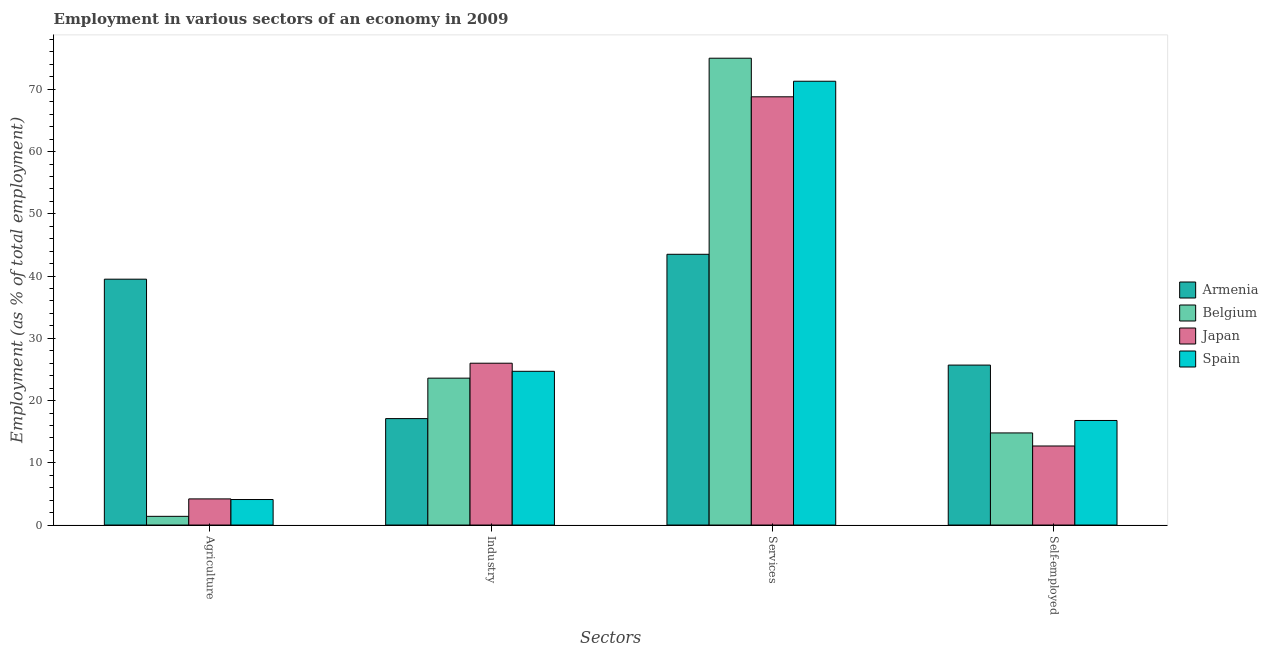How many bars are there on the 4th tick from the left?
Offer a very short reply. 4. What is the label of the 2nd group of bars from the left?
Offer a very short reply. Industry. What is the percentage of self employed workers in Spain?
Provide a succinct answer. 16.8. Across all countries, what is the maximum percentage of workers in agriculture?
Your answer should be very brief. 39.5. Across all countries, what is the minimum percentage of workers in industry?
Ensure brevity in your answer.  17.1. In which country was the percentage of workers in agriculture maximum?
Give a very brief answer. Armenia. In which country was the percentage of workers in agriculture minimum?
Offer a terse response. Belgium. What is the total percentage of self employed workers in the graph?
Offer a very short reply. 70. What is the difference between the percentage of workers in industry in Japan and that in Armenia?
Your answer should be very brief. 8.9. What is the difference between the percentage of workers in services in Spain and the percentage of workers in industry in Belgium?
Your answer should be compact. 47.7. What is the average percentage of self employed workers per country?
Ensure brevity in your answer.  17.5. What is the difference between the percentage of workers in industry and percentage of workers in services in Belgium?
Your response must be concise. -51.4. What is the ratio of the percentage of self employed workers in Spain to that in Belgium?
Your answer should be very brief. 1.14. Is the percentage of workers in agriculture in Spain less than that in Belgium?
Your answer should be compact. No. Is the difference between the percentage of self employed workers in Armenia and Spain greater than the difference between the percentage of workers in industry in Armenia and Spain?
Give a very brief answer. Yes. What is the difference between the highest and the second highest percentage of self employed workers?
Keep it short and to the point. 8.9. What is the difference between the highest and the lowest percentage of workers in industry?
Make the answer very short. 8.9. What does the 1st bar from the left in Services represents?
Your response must be concise. Armenia. What does the 4th bar from the right in Self-employed represents?
Offer a very short reply. Armenia. Does the graph contain any zero values?
Ensure brevity in your answer.  No. Where does the legend appear in the graph?
Offer a very short reply. Center right. What is the title of the graph?
Make the answer very short. Employment in various sectors of an economy in 2009. Does "Vanuatu" appear as one of the legend labels in the graph?
Offer a terse response. No. What is the label or title of the X-axis?
Provide a short and direct response. Sectors. What is the label or title of the Y-axis?
Your response must be concise. Employment (as % of total employment). What is the Employment (as % of total employment) in Armenia in Agriculture?
Offer a terse response. 39.5. What is the Employment (as % of total employment) in Belgium in Agriculture?
Offer a very short reply. 1.4. What is the Employment (as % of total employment) of Japan in Agriculture?
Make the answer very short. 4.2. What is the Employment (as % of total employment) in Spain in Agriculture?
Your response must be concise. 4.1. What is the Employment (as % of total employment) in Armenia in Industry?
Your answer should be compact. 17.1. What is the Employment (as % of total employment) in Belgium in Industry?
Offer a very short reply. 23.6. What is the Employment (as % of total employment) in Spain in Industry?
Offer a terse response. 24.7. What is the Employment (as % of total employment) in Armenia in Services?
Make the answer very short. 43.5. What is the Employment (as % of total employment) in Japan in Services?
Provide a short and direct response. 68.8. What is the Employment (as % of total employment) of Spain in Services?
Your answer should be very brief. 71.3. What is the Employment (as % of total employment) of Armenia in Self-employed?
Provide a short and direct response. 25.7. What is the Employment (as % of total employment) in Belgium in Self-employed?
Ensure brevity in your answer.  14.8. What is the Employment (as % of total employment) in Japan in Self-employed?
Offer a terse response. 12.7. What is the Employment (as % of total employment) in Spain in Self-employed?
Your answer should be very brief. 16.8. Across all Sectors, what is the maximum Employment (as % of total employment) of Armenia?
Give a very brief answer. 43.5. Across all Sectors, what is the maximum Employment (as % of total employment) of Belgium?
Offer a terse response. 75. Across all Sectors, what is the maximum Employment (as % of total employment) of Japan?
Make the answer very short. 68.8. Across all Sectors, what is the maximum Employment (as % of total employment) in Spain?
Ensure brevity in your answer.  71.3. Across all Sectors, what is the minimum Employment (as % of total employment) of Armenia?
Keep it short and to the point. 17.1. Across all Sectors, what is the minimum Employment (as % of total employment) of Belgium?
Provide a succinct answer. 1.4. Across all Sectors, what is the minimum Employment (as % of total employment) in Japan?
Provide a short and direct response. 4.2. Across all Sectors, what is the minimum Employment (as % of total employment) of Spain?
Your response must be concise. 4.1. What is the total Employment (as % of total employment) of Armenia in the graph?
Your answer should be compact. 125.8. What is the total Employment (as % of total employment) in Belgium in the graph?
Your answer should be very brief. 114.8. What is the total Employment (as % of total employment) in Japan in the graph?
Your answer should be very brief. 111.7. What is the total Employment (as % of total employment) of Spain in the graph?
Make the answer very short. 116.9. What is the difference between the Employment (as % of total employment) in Armenia in Agriculture and that in Industry?
Give a very brief answer. 22.4. What is the difference between the Employment (as % of total employment) of Belgium in Agriculture and that in Industry?
Offer a terse response. -22.2. What is the difference between the Employment (as % of total employment) of Japan in Agriculture and that in Industry?
Ensure brevity in your answer.  -21.8. What is the difference between the Employment (as % of total employment) in Spain in Agriculture and that in Industry?
Your response must be concise. -20.6. What is the difference between the Employment (as % of total employment) in Belgium in Agriculture and that in Services?
Your answer should be very brief. -73.6. What is the difference between the Employment (as % of total employment) of Japan in Agriculture and that in Services?
Offer a very short reply. -64.6. What is the difference between the Employment (as % of total employment) in Spain in Agriculture and that in Services?
Your answer should be very brief. -67.2. What is the difference between the Employment (as % of total employment) of Belgium in Agriculture and that in Self-employed?
Provide a short and direct response. -13.4. What is the difference between the Employment (as % of total employment) of Japan in Agriculture and that in Self-employed?
Give a very brief answer. -8.5. What is the difference between the Employment (as % of total employment) in Armenia in Industry and that in Services?
Make the answer very short. -26.4. What is the difference between the Employment (as % of total employment) of Belgium in Industry and that in Services?
Offer a terse response. -51.4. What is the difference between the Employment (as % of total employment) of Japan in Industry and that in Services?
Keep it short and to the point. -42.8. What is the difference between the Employment (as % of total employment) of Spain in Industry and that in Services?
Offer a terse response. -46.6. What is the difference between the Employment (as % of total employment) of Armenia in Industry and that in Self-employed?
Make the answer very short. -8.6. What is the difference between the Employment (as % of total employment) in Belgium in Industry and that in Self-employed?
Offer a very short reply. 8.8. What is the difference between the Employment (as % of total employment) of Japan in Industry and that in Self-employed?
Provide a succinct answer. 13.3. What is the difference between the Employment (as % of total employment) of Belgium in Services and that in Self-employed?
Make the answer very short. 60.2. What is the difference between the Employment (as % of total employment) in Japan in Services and that in Self-employed?
Provide a short and direct response. 56.1. What is the difference between the Employment (as % of total employment) of Spain in Services and that in Self-employed?
Keep it short and to the point. 54.5. What is the difference between the Employment (as % of total employment) of Armenia in Agriculture and the Employment (as % of total employment) of Spain in Industry?
Your answer should be compact. 14.8. What is the difference between the Employment (as % of total employment) of Belgium in Agriculture and the Employment (as % of total employment) of Japan in Industry?
Offer a terse response. -24.6. What is the difference between the Employment (as % of total employment) in Belgium in Agriculture and the Employment (as % of total employment) in Spain in Industry?
Ensure brevity in your answer.  -23.3. What is the difference between the Employment (as % of total employment) of Japan in Agriculture and the Employment (as % of total employment) of Spain in Industry?
Give a very brief answer. -20.5. What is the difference between the Employment (as % of total employment) of Armenia in Agriculture and the Employment (as % of total employment) of Belgium in Services?
Give a very brief answer. -35.5. What is the difference between the Employment (as % of total employment) of Armenia in Agriculture and the Employment (as % of total employment) of Japan in Services?
Provide a succinct answer. -29.3. What is the difference between the Employment (as % of total employment) of Armenia in Agriculture and the Employment (as % of total employment) of Spain in Services?
Give a very brief answer. -31.8. What is the difference between the Employment (as % of total employment) in Belgium in Agriculture and the Employment (as % of total employment) in Japan in Services?
Your answer should be very brief. -67.4. What is the difference between the Employment (as % of total employment) in Belgium in Agriculture and the Employment (as % of total employment) in Spain in Services?
Ensure brevity in your answer.  -69.9. What is the difference between the Employment (as % of total employment) in Japan in Agriculture and the Employment (as % of total employment) in Spain in Services?
Provide a short and direct response. -67.1. What is the difference between the Employment (as % of total employment) of Armenia in Agriculture and the Employment (as % of total employment) of Belgium in Self-employed?
Make the answer very short. 24.7. What is the difference between the Employment (as % of total employment) in Armenia in Agriculture and the Employment (as % of total employment) in Japan in Self-employed?
Your answer should be very brief. 26.8. What is the difference between the Employment (as % of total employment) of Armenia in Agriculture and the Employment (as % of total employment) of Spain in Self-employed?
Offer a terse response. 22.7. What is the difference between the Employment (as % of total employment) in Belgium in Agriculture and the Employment (as % of total employment) in Spain in Self-employed?
Give a very brief answer. -15.4. What is the difference between the Employment (as % of total employment) in Japan in Agriculture and the Employment (as % of total employment) in Spain in Self-employed?
Offer a terse response. -12.6. What is the difference between the Employment (as % of total employment) in Armenia in Industry and the Employment (as % of total employment) in Belgium in Services?
Your response must be concise. -57.9. What is the difference between the Employment (as % of total employment) in Armenia in Industry and the Employment (as % of total employment) in Japan in Services?
Make the answer very short. -51.7. What is the difference between the Employment (as % of total employment) of Armenia in Industry and the Employment (as % of total employment) of Spain in Services?
Make the answer very short. -54.2. What is the difference between the Employment (as % of total employment) of Belgium in Industry and the Employment (as % of total employment) of Japan in Services?
Provide a short and direct response. -45.2. What is the difference between the Employment (as % of total employment) in Belgium in Industry and the Employment (as % of total employment) in Spain in Services?
Provide a succinct answer. -47.7. What is the difference between the Employment (as % of total employment) of Japan in Industry and the Employment (as % of total employment) of Spain in Services?
Give a very brief answer. -45.3. What is the difference between the Employment (as % of total employment) of Armenia in Industry and the Employment (as % of total employment) of Belgium in Self-employed?
Keep it short and to the point. 2.3. What is the difference between the Employment (as % of total employment) of Armenia in Industry and the Employment (as % of total employment) of Japan in Self-employed?
Give a very brief answer. 4.4. What is the difference between the Employment (as % of total employment) of Japan in Industry and the Employment (as % of total employment) of Spain in Self-employed?
Provide a succinct answer. 9.2. What is the difference between the Employment (as % of total employment) in Armenia in Services and the Employment (as % of total employment) in Belgium in Self-employed?
Keep it short and to the point. 28.7. What is the difference between the Employment (as % of total employment) in Armenia in Services and the Employment (as % of total employment) in Japan in Self-employed?
Provide a succinct answer. 30.8. What is the difference between the Employment (as % of total employment) in Armenia in Services and the Employment (as % of total employment) in Spain in Self-employed?
Offer a very short reply. 26.7. What is the difference between the Employment (as % of total employment) in Belgium in Services and the Employment (as % of total employment) in Japan in Self-employed?
Give a very brief answer. 62.3. What is the difference between the Employment (as % of total employment) of Belgium in Services and the Employment (as % of total employment) of Spain in Self-employed?
Give a very brief answer. 58.2. What is the average Employment (as % of total employment) of Armenia per Sectors?
Make the answer very short. 31.45. What is the average Employment (as % of total employment) of Belgium per Sectors?
Give a very brief answer. 28.7. What is the average Employment (as % of total employment) in Japan per Sectors?
Give a very brief answer. 27.93. What is the average Employment (as % of total employment) of Spain per Sectors?
Ensure brevity in your answer.  29.23. What is the difference between the Employment (as % of total employment) of Armenia and Employment (as % of total employment) of Belgium in Agriculture?
Give a very brief answer. 38.1. What is the difference between the Employment (as % of total employment) in Armenia and Employment (as % of total employment) in Japan in Agriculture?
Offer a very short reply. 35.3. What is the difference between the Employment (as % of total employment) in Armenia and Employment (as % of total employment) in Spain in Agriculture?
Keep it short and to the point. 35.4. What is the difference between the Employment (as % of total employment) of Belgium and Employment (as % of total employment) of Japan in Agriculture?
Offer a very short reply. -2.8. What is the difference between the Employment (as % of total employment) of Belgium and Employment (as % of total employment) of Spain in Agriculture?
Keep it short and to the point. -2.7. What is the difference between the Employment (as % of total employment) in Japan and Employment (as % of total employment) in Spain in Agriculture?
Offer a terse response. 0.1. What is the difference between the Employment (as % of total employment) in Armenia and Employment (as % of total employment) in Belgium in Industry?
Your answer should be compact. -6.5. What is the difference between the Employment (as % of total employment) in Belgium and Employment (as % of total employment) in Spain in Industry?
Your response must be concise. -1.1. What is the difference between the Employment (as % of total employment) in Japan and Employment (as % of total employment) in Spain in Industry?
Provide a succinct answer. 1.3. What is the difference between the Employment (as % of total employment) in Armenia and Employment (as % of total employment) in Belgium in Services?
Provide a succinct answer. -31.5. What is the difference between the Employment (as % of total employment) in Armenia and Employment (as % of total employment) in Japan in Services?
Offer a terse response. -25.3. What is the difference between the Employment (as % of total employment) of Armenia and Employment (as % of total employment) of Spain in Services?
Make the answer very short. -27.8. What is the difference between the Employment (as % of total employment) of Belgium and Employment (as % of total employment) of Japan in Services?
Give a very brief answer. 6.2. What is the difference between the Employment (as % of total employment) of Japan and Employment (as % of total employment) of Spain in Services?
Give a very brief answer. -2.5. What is the difference between the Employment (as % of total employment) of Belgium and Employment (as % of total employment) of Japan in Self-employed?
Your response must be concise. 2.1. What is the difference between the Employment (as % of total employment) of Belgium and Employment (as % of total employment) of Spain in Self-employed?
Your answer should be compact. -2. What is the ratio of the Employment (as % of total employment) of Armenia in Agriculture to that in Industry?
Provide a short and direct response. 2.31. What is the ratio of the Employment (as % of total employment) in Belgium in Agriculture to that in Industry?
Provide a short and direct response. 0.06. What is the ratio of the Employment (as % of total employment) in Japan in Agriculture to that in Industry?
Provide a short and direct response. 0.16. What is the ratio of the Employment (as % of total employment) in Spain in Agriculture to that in Industry?
Give a very brief answer. 0.17. What is the ratio of the Employment (as % of total employment) of Armenia in Agriculture to that in Services?
Offer a very short reply. 0.91. What is the ratio of the Employment (as % of total employment) of Belgium in Agriculture to that in Services?
Make the answer very short. 0.02. What is the ratio of the Employment (as % of total employment) of Japan in Agriculture to that in Services?
Keep it short and to the point. 0.06. What is the ratio of the Employment (as % of total employment) of Spain in Agriculture to that in Services?
Your response must be concise. 0.06. What is the ratio of the Employment (as % of total employment) of Armenia in Agriculture to that in Self-employed?
Your answer should be very brief. 1.54. What is the ratio of the Employment (as % of total employment) of Belgium in Agriculture to that in Self-employed?
Offer a terse response. 0.09. What is the ratio of the Employment (as % of total employment) in Japan in Agriculture to that in Self-employed?
Provide a succinct answer. 0.33. What is the ratio of the Employment (as % of total employment) in Spain in Agriculture to that in Self-employed?
Provide a succinct answer. 0.24. What is the ratio of the Employment (as % of total employment) of Armenia in Industry to that in Services?
Provide a succinct answer. 0.39. What is the ratio of the Employment (as % of total employment) in Belgium in Industry to that in Services?
Provide a short and direct response. 0.31. What is the ratio of the Employment (as % of total employment) in Japan in Industry to that in Services?
Make the answer very short. 0.38. What is the ratio of the Employment (as % of total employment) of Spain in Industry to that in Services?
Ensure brevity in your answer.  0.35. What is the ratio of the Employment (as % of total employment) in Armenia in Industry to that in Self-employed?
Provide a succinct answer. 0.67. What is the ratio of the Employment (as % of total employment) in Belgium in Industry to that in Self-employed?
Offer a very short reply. 1.59. What is the ratio of the Employment (as % of total employment) in Japan in Industry to that in Self-employed?
Your answer should be compact. 2.05. What is the ratio of the Employment (as % of total employment) of Spain in Industry to that in Self-employed?
Keep it short and to the point. 1.47. What is the ratio of the Employment (as % of total employment) of Armenia in Services to that in Self-employed?
Your answer should be very brief. 1.69. What is the ratio of the Employment (as % of total employment) of Belgium in Services to that in Self-employed?
Offer a very short reply. 5.07. What is the ratio of the Employment (as % of total employment) in Japan in Services to that in Self-employed?
Provide a succinct answer. 5.42. What is the ratio of the Employment (as % of total employment) of Spain in Services to that in Self-employed?
Offer a very short reply. 4.24. What is the difference between the highest and the second highest Employment (as % of total employment) in Belgium?
Provide a short and direct response. 51.4. What is the difference between the highest and the second highest Employment (as % of total employment) in Japan?
Provide a succinct answer. 42.8. What is the difference between the highest and the second highest Employment (as % of total employment) of Spain?
Give a very brief answer. 46.6. What is the difference between the highest and the lowest Employment (as % of total employment) in Armenia?
Provide a short and direct response. 26.4. What is the difference between the highest and the lowest Employment (as % of total employment) in Belgium?
Your answer should be compact. 73.6. What is the difference between the highest and the lowest Employment (as % of total employment) of Japan?
Make the answer very short. 64.6. What is the difference between the highest and the lowest Employment (as % of total employment) of Spain?
Offer a very short reply. 67.2. 